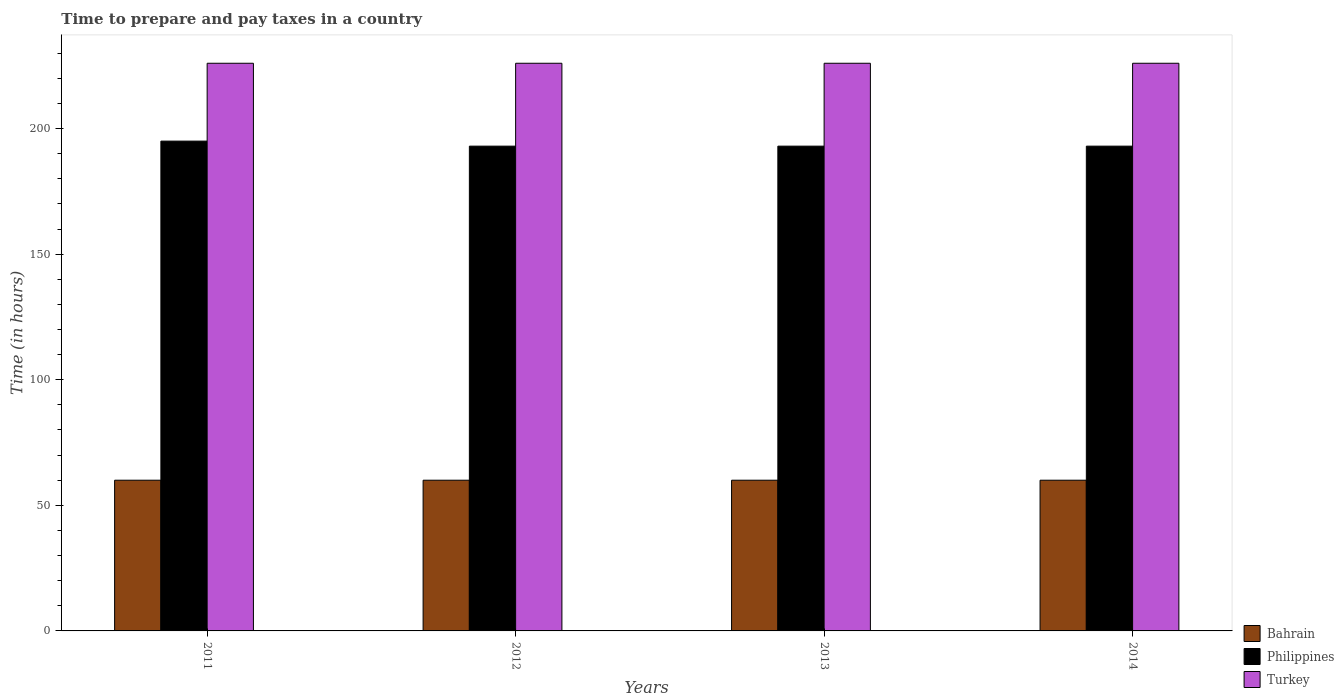How many groups of bars are there?
Keep it short and to the point. 4. Are the number of bars on each tick of the X-axis equal?
Ensure brevity in your answer.  Yes. What is the label of the 4th group of bars from the left?
Offer a very short reply. 2014. What is the number of hours required to prepare and pay taxes in Bahrain in 2012?
Offer a terse response. 60. Across all years, what is the maximum number of hours required to prepare and pay taxes in Turkey?
Your answer should be compact. 226. What is the total number of hours required to prepare and pay taxes in Turkey in the graph?
Ensure brevity in your answer.  904. What is the difference between the number of hours required to prepare and pay taxes in Turkey in 2011 and that in 2012?
Ensure brevity in your answer.  0. What is the difference between the number of hours required to prepare and pay taxes in Bahrain in 2014 and the number of hours required to prepare and pay taxes in Turkey in 2012?
Keep it short and to the point. -166. What is the average number of hours required to prepare and pay taxes in Bahrain per year?
Give a very brief answer. 60. In the year 2014, what is the difference between the number of hours required to prepare and pay taxes in Bahrain and number of hours required to prepare and pay taxes in Philippines?
Offer a very short reply. -133. Is the number of hours required to prepare and pay taxes in Philippines in 2013 less than that in 2014?
Your answer should be very brief. No. Is the difference between the number of hours required to prepare and pay taxes in Bahrain in 2012 and 2014 greater than the difference between the number of hours required to prepare and pay taxes in Philippines in 2012 and 2014?
Provide a short and direct response. No. What is the difference between the highest and the second highest number of hours required to prepare and pay taxes in Philippines?
Keep it short and to the point. 2. What does the 1st bar from the right in 2014 represents?
Keep it short and to the point. Turkey. How many bars are there?
Offer a very short reply. 12. How many years are there in the graph?
Provide a succinct answer. 4. What is the difference between two consecutive major ticks on the Y-axis?
Your answer should be compact. 50. Does the graph contain any zero values?
Keep it short and to the point. No. What is the title of the graph?
Your response must be concise. Time to prepare and pay taxes in a country. What is the label or title of the X-axis?
Ensure brevity in your answer.  Years. What is the label or title of the Y-axis?
Your response must be concise. Time (in hours). What is the Time (in hours) of Philippines in 2011?
Make the answer very short. 195. What is the Time (in hours) of Turkey in 2011?
Offer a terse response. 226. What is the Time (in hours) of Philippines in 2012?
Your response must be concise. 193. What is the Time (in hours) of Turkey in 2012?
Make the answer very short. 226. What is the Time (in hours) of Bahrain in 2013?
Provide a short and direct response. 60. What is the Time (in hours) of Philippines in 2013?
Your answer should be compact. 193. What is the Time (in hours) in Turkey in 2013?
Provide a short and direct response. 226. What is the Time (in hours) of Philippines in 2014?
Your response must be concise. 193. What is the Time (in hours) in Turkey in 2014?
Offer a very short reply. 226. Across all years, what is the maximum Time (in hours) in Bahrain?
Your answer should be very brief. 60. Across all years, what is the maximum Time (in hours) in Philippines?
Make the answer very short. 195. Across all years, what is the maximum Time (in hours) of Turkey?
Offer a terse response. 226. Across all years, what is the minimum Time (in hours) of Bahrain?
Give a very brief answer. 60. Across all years, what is the minimum Time (in hours) in Philippines?
Give a very brief answer. 193. Across all years, what is the minimum Time (in hours) of Turkey?
Ensure brevity in your answer.  226. What is the total Time (in hours) in Bahrain in the graph?
Keep it short and to the point. 240. What is the total Time (in hours) in Philippines in the graph?
Provide a succinct answer. 774. What is the total Time (in hours) of Turkey in the graph?
Offer a terse response. 904. What is the difference between the Time (in hours) in Bahrain in 2011 and that in 2012?
Provide a short and direct response. 0. What is the difference between the Time (in hours) in Turkey in 2011 and that in 2012?
Offer a terse response. 0. What is the difference between the Time (in hours) of Bahrain in 2011 and that in 2014?
Keep it short and to the point. 0. What is the difference between the Time (in hours) in Philippines in 2011 and that in 2014?
Your response must be concise. 2. What is the difference between the Time (in hours) in Turkey in 2011 and that in 2014?
Your answer should be very brief. 0. What is the difference between the Time (in hours) of Bahrain in 2012 and that in 2013?
Your answer should be compact. 0. What is the difference between the Time (in hours) of Philippines in 2012 and that in 2013?
Ensure brevity in your answer.  0. What is the difference between the Time (in hours) in Turkey in 2012 and that in 2013?
Your response must be concise. 0. What is the difference between the Time (in hours) in Bahrain in 2012 and that in 2014?
Keep it short and to the point. 0. What is the difference between the Time (in hours) of Bahrain in 2013 and that in 2014?
Your answer should be very brief. 0. What is the difference between the Time (in hours) of Turkey in 2013 and that in 2014?
Ensure brevity in your answer.  0. What is the difference between the Time (in hours) in Bahrain in 2011 and the Time (in hours) in Philippines in 2012?
Provide a succinct answer. -133. What is the difference between the Time (in hours) in Bahrain in 2011 and the Time (in hours) in Turkey in 2012?
Provide a short and direct response. -166. What is the difference between the Time (in hours) of Philippines in 2011 and the Time (in hours) of Turkey in 2012?
Provide a short and direct response. -31. What is the difference between the Time (in hours) of Bahrain in 2011 and the Time (in hours) of Philippines in 2013?
Offer a very short reply. -133. What is the difference between the Time (in hours) in Bahrain in 2011 and the Time (in hours) in Turkey in 2013?
Provide a succinct answer. -166. What is the difference between the Time (in hours) in Philippines in 2011 and the Time (in hours) in Turkey in 2013?
Your answer should be compact. -31. What is the difference between the Time (in hours) of Bahrain in 2011 and the Time (in hours) of Philippines in 2014?
Provide a short and direct response. -133. What is the difference between the Time (in hours) in Bahrain in 2011 and the Time (in hours) in Turkey in 2014?
Offer a terse response. -166. What is the difference between the Time (in hours) of Philippines in 2011 and the Time (in hours) of Turkey in 2014?
Offer a very short reply. -31. What is the difference between the Time (in hours) of Bahrain in 2012 and the Time (in hours) of Philippines in 2013?
Your answer should be very brief. -133. What is the difference between the Time (in hours) in Bahrain in 2012 and the Time (in hours) in Turkey in 2013?
Provide a succinct answer. -166. What is the difference between the Time (in hours) in Philippines in 2012 and the Time (in hours) in Turkey in 2013?
Give a very brief answer. -33. What is the difference between the Time (in hours) in Bahrain in 2012 and the Time (in hours) in Philippines in 2014?
Ensure brevity in your answer.  -133. What is the difference between the Time (in hours) in Bahrain in 2012 and the Time (in hours) in Turkey in 2014?
Your response must be concise. -166. What is the difference between the Time (in hours) of Philippines in 2012 and the Time (in hours) of Turkey in 2014?
Provide a short and direct response. -33. What is the difference between the Time (in hours) in Bahrain in 2013 and the Time (in hours) in Philippines in 2014?
Make the answer very short. -133. What is the difference between the Time (in hours) in Bahrain in 2013 and the Time (in hours) in Turkey in 2014?
Offer a very short reply. -166. What is the difference between the Time (in hours) of Philippines in 2013 and the Time (in hours) of Turkey in 2014?
Your answer should be compact. -33. What is the average Time (in hours) in Philippines per year?
Offer a terse response. 193.5. What is the average Time (in hours) of Turkey per year?
Make the answer very short. 226. In the year 2011, what is the difference between the Time (in hours) of Bahrain and Time (in hours) of Philippines?
Give a very brief answer. -135. In the year 2011, what is the difference between the Time (in hours) of Bahrain and Time (in hours) of Turkey?
Provide a short and direct response. -166. In the year 2011, what is the difference between the Time (in hours) in Philippines and Time (in hours) in Turkey?
Make the answer very short. -31. In the year 2012, what is the difference between the Time (in hours) in Bahrain and Time (in hours) in Philippines?
Offer a terse response. -133. In the year 2012, what is the difference between the Time (in hours) of Bahrain and Time (in hours) of Turkey?
Ensure brevity in your answer.  -166. In the year 2012, what is the difference between the Time (in hours) in Philippines and Time (in hours) in Turkey?
Offer a very short reply. -33. In the year 2013, what is the difference between the Time (in hours) of Bahrain and Time (in hours) of Philippines?
Give a very brief answer. -133. In the year 2013, what is the difference between the Time (in hours) in Bahrain and Time (in hours) in Turkey?
Ensure brevity in your answer.  -166. In the year 2013, what is the difference between the Time (in hours) in Philippines and Time (in hours) in Turkey?
Your answer should be very brief. -33. In the year 2014, what is the difference between the Time (in hours) of Bahrain and Time (in hours) of Philippines?
Your answer should be compact. -133. In the year 2014, what is the difference between the Time (in hours) of Bahrain and Time (in hours) of Turkey?
Your answer should be compact. -166. In the year 2014, what is the difference between the Time (in hours) of Philippines and Time (in hours) of Turkey?
Keep it short and to the point. -33. What is the ratio of the Time (in hours) in Philippines in 2011 to that in 2012?
Ensure brevity in your answer.  1.01. What is the ratio of the Time (in hours) in Philippines in 2011 to that in 2013?
Offer a terse response. 1.01. What is the ratio of the Time (in hours) of Turkey in 2011 to that in 2013?
Provide a succinct answer. 1. What is the ratio of the Time (in hours) of Bahrain in 2011 to that in 2014?
Ensure brevity in your answer.  1. What is the ratio of the Time (in hours) of Philippines in 2011 to that in 2014?
Keep it short and to the point. 1.01. What is the ratio of the Time (in hours) of Turkey in 2011 to that in 2014?
Provide a succinct answer. 1. What is the ratio of the Time (in hours) in Bahrain in 2012 to that in 2013?
Make the answer very short. 1. What is the ratio of the Time (in hours) in Turkey in 2012 to that in 2014?
Keep it short and to the point. 1. What is the ratio of the Time (in hours) of Bahrain in 2013 to that in 2014?
Your response must be concise. 1. What is the ratio of the Time (in hours) in Philippines in 2013 to that in 2014?
Give a very brief answer. 1. What is the difference between the highest and the second highest Time (in hours) in Bahrain?
Provide a short and direct response. 0. What is the difference between the highest and the second highest Time (in hours) of Philippines?
Keep it short and to the point. 2. What is the difference between the highest and the second highest Time (in hours) of Turkey?
Ensure brevity in your answer.  0. What is the difference between the highest and the lowest Time (in hours) of Bahrain?
Give a very brief answer. 0. What is the difference between the highest and the lowest Time (in hours) in Philippines?
Provide a succinct answer. 2. What is the difference between the highest and the lowest Time (in hours) in Turkey?
Provide a succinct answer. 0. 